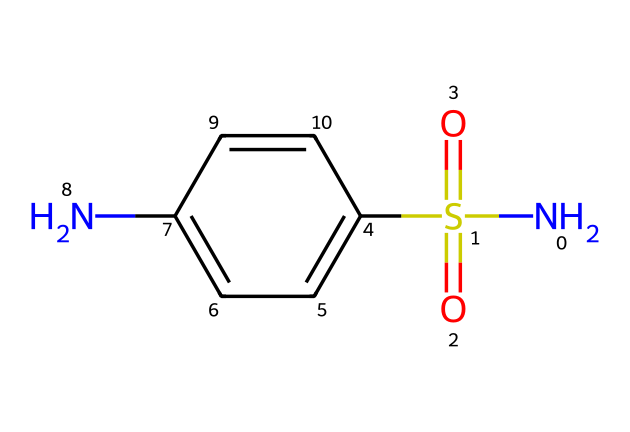What is the core functional group present in sulfanilamide? The SMILES representation includes the sulfonamide group, which is indicated by the presence of the sulfur atom (S) bonded to two oxygen atoms (O) in a sulfonyl (–SO2–) configuration and bonded to a nitrogen (N) atom.
Answer: sulfonamide How many nitrogen atoms are in sulfanilamide? By analyzing the SMILES representation, we find that there is one nitrogen atom (indicated by 'N') in the structure of sulfanilamide.
Answer: one What is the total number of aromatic rings in sulfanilamide? The structure contains one aromatic ring, which is indicated by the cyclic part of the molecule (the 'c1ccc...') in the SMILES notation.
Answer: one Which part of the molecule is responsible for its antibiotic activity? The sulfonamide functional group (sulfur coupled with nitrogen) contains the element that imparts antibacterial properties, as it mimics para-aminobenzoic acid, necessary for bacterial growth.
Answer: sulfonamide How many oxygen atoms are present in sulfanilamide? In the SMILES notation, 'O' appears twice, indicating that there are two oxygen atoms associated with the sulfonamide group in sulfanilamide.
Answer: two What is the role of the amine group in sulfanilamide? The amine group (–NH2) plays a crucial role in enhancing the solubility of sulfanilamide in water and also contributes to its biological activity by forming hydrogen bonds with target enzymes in bacteria.
Answer: enhance solubility What is the molecular formula of sulfanilamide? From the structure indicated in the SMILES, we can deduce the molecular formula by counting the different atoms: C, H, N, O, S which gives us C6H8N2O2S, summarizing the entire composition.
Answer: C6H8N2O2S 